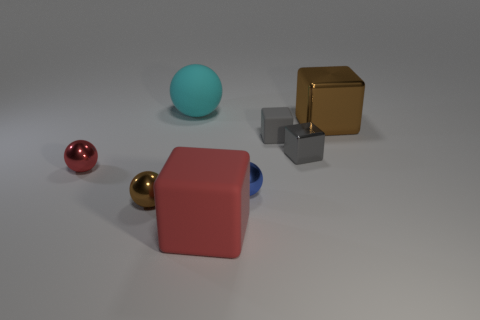There is a thing that is the same color as the large metal cube; what is its shape?
Your answer should be compact. Sphere. What number of big cyan rubber objects have the same shape as the small brown metal object?
Ensure brevity in your answer.  1. There is a shiny ball right of the red object that is in front of the red metal thing; what size is it?
Offer a terse response. Small. Is the size of the red metallic object the same as the cyan object?
Make the answer very short. No. Is there a big brown shiny object that is left of the ball behind the red object on the left side of the cyan matte ball?
Offer a terse response. No. The cyan ball has what size?
Make the answer very short. Large. What number of green metal balls have the same size as the cyan rubber sphere?
Your answer should be compact. 0. There is another big red object that is the same shape as the large metallic thing; what material is it?
Offer a terse response. Rubber. What shape is the large object that is both behind the small gray shiny thing and on the left side of the brown shiny cube?
Provide a succinct answer. Sphere. What is the shape of the red thing to the right of the red metal thing?
Offer a very short reply. Cube. 